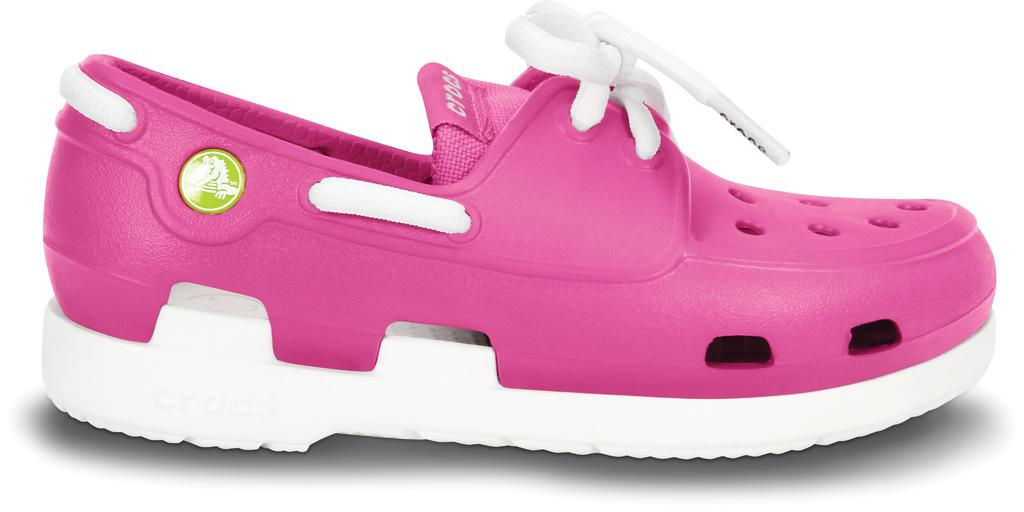What color is the shoe that is visible in the image? The shoe in the image is pink and white. What color is the background of the image? The background of the image is white. How many people are in the group that is cooking in the image? There is no group of people cooking in the image; it only features a pink and white shoe against a white background. 